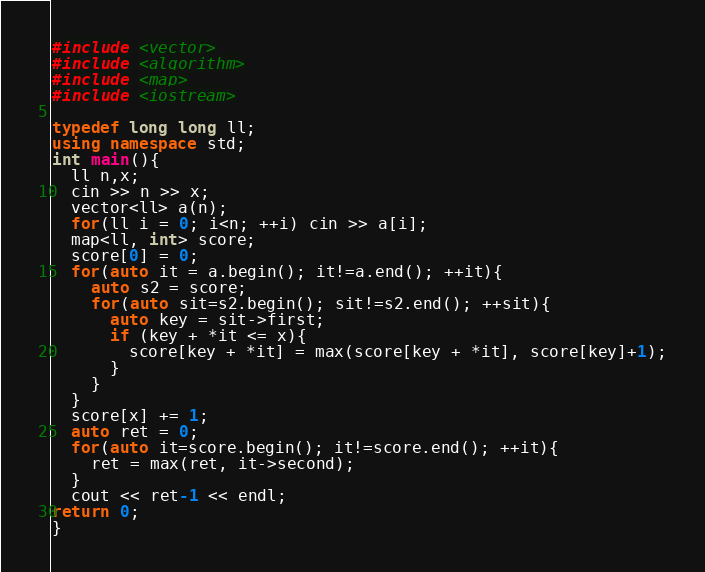<code> <loc_0><loc_0><loc_500><loc_500><_C++_>#include <vector>
#include <algorithm>
#include <map>
#include <iostream>

typedef long long ll;
using namespace std;
int main(){
  ll n,x;
  cin >> n >> x;
  vector<ll> a(n);
  for(ll i = 0; i<n; ++i) cin >> a[i];
  map<ll, int> score;
  score[0] = 0;
  for(auto it = a.begin(); it!=a.end(); ++it){
    auto s2 = score;
    for(auto sit=s2.begin(); sit!=s2.end(); ++sit){
      auto key = sit->first;
      if (key + *it <= x){
        score[key + *it] = max(score[key + *it], score[key]+1);
      }
    }
  }
  score[x] += 1;
  auto ret = 0;
  for(auto it=score.begin(); it!=score.end(); ++it){
    ret = max(ret, it->second);
  }
  cout << ret-1 << endl;
return 0;
}</code> 